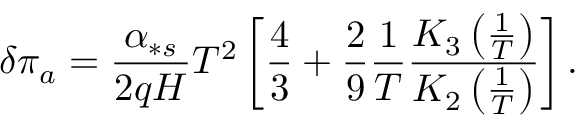<formula> <loc_0><loc_0><loc_500><loc_500>\delta \pi _ { a } = \frac { \alpha _ { \ast s } } { 2 q H } T ^ { 2 } \left [ \frac { 4 } { 3 } + \frac { 2 } { 9 } \frac { 1 } { T } \frac { K _ { 3 } \left ( \frac { 1 } { T } \right ) } { K _ { 2 } \left ( \frac { 1 } { T } \right ) } \right ] .</formula> 